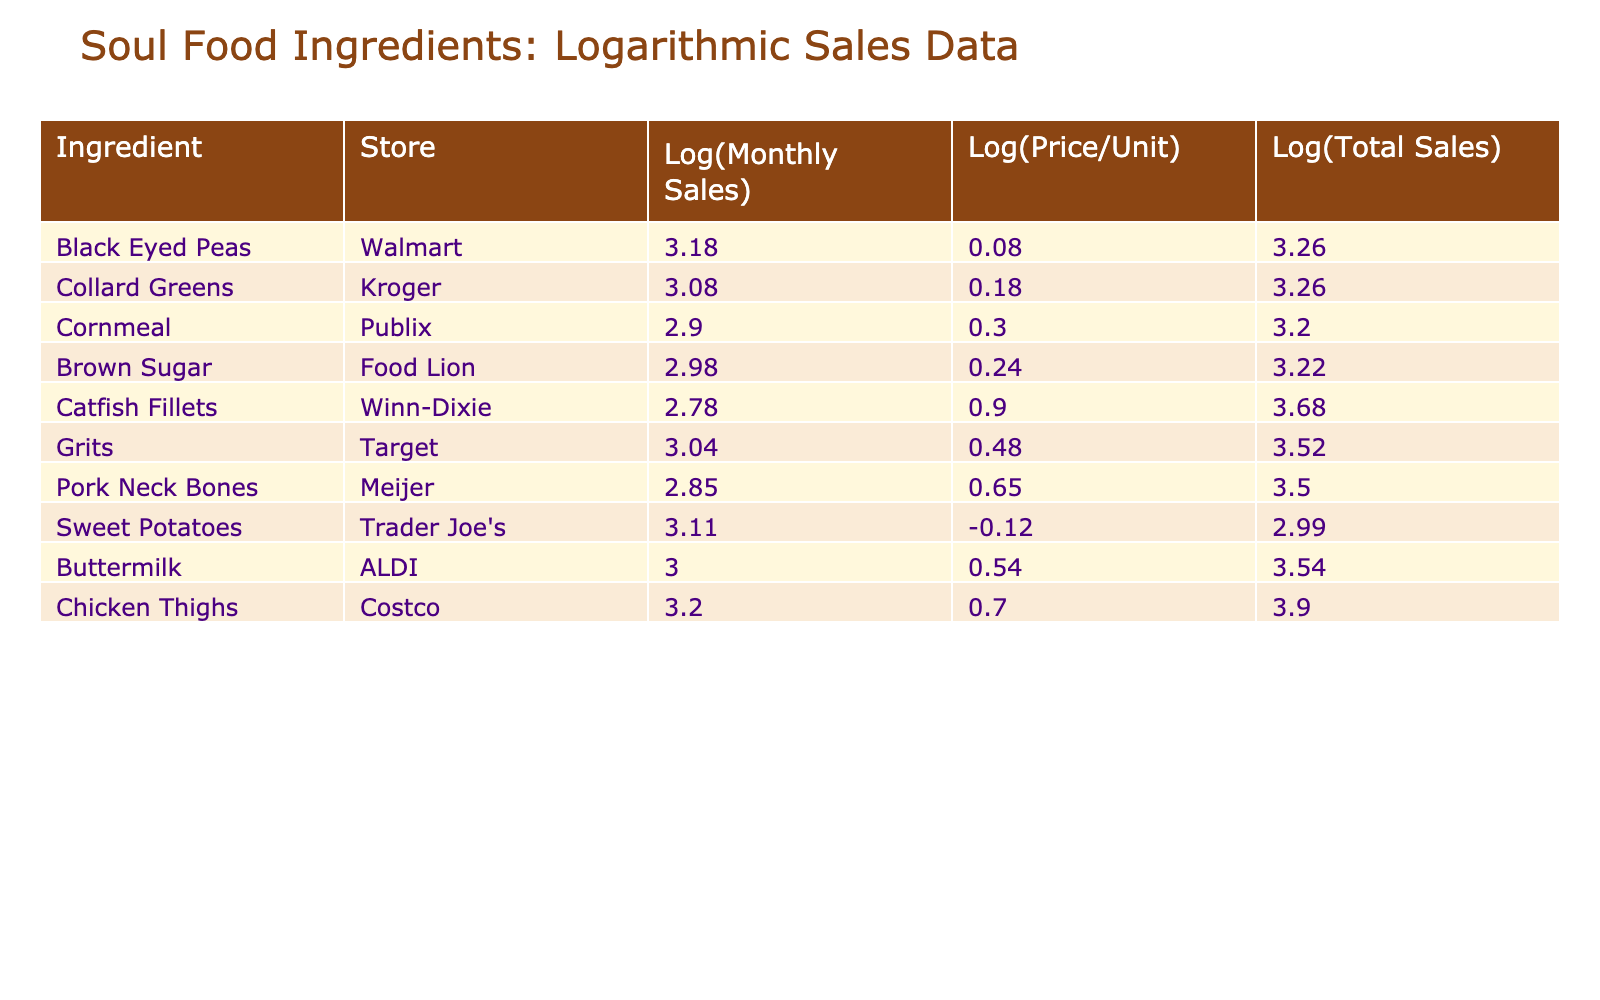What is the logarithmic value of the Monthly Sales Units for Catfish Fillets? The logarithmic value can be found in the "Log(Monthly Sales)" column for Catfish Fillets, which has 600 Monthly Sales Units. By calculating log10(600), we find it to be approximately 2.78.
Answer: 2.78 Which store sells the most log-transformed number of Monthly Sales Units of Grits? The log-transformed value for Grits in Target is found in the "Log(Monthly Sales)" column, which is approximately 3.04. There are no other stores selling Grits, so Target is the only store for this ingredient.
Answer: Target What is the total sales rounded to the nearest integer for the ingredient with the highest logarithmic value of Price Per Unit? The ingredient with the highest Price Per Unit is Catfish Fillets, priced at 8.00, and its Total Sales is 4800. The logarithmic value for Price Per Unit is log10(8.00) which is about 0.90. Hence, since it has the highest price, the Total Sales for Catfish Fillets is already known as 4800 when rounded to the nearest integer.
Answer: 4800 Is the log-transformed Total Sales of Black Eyed Peas greater than that of Collard Greens? The logarithmic value for Total Sales of Black Eyed Peas is log10(1800) which is approximately 3.25, while for Collard Greens the value is log10(1800), which is the same, approximately 3.25. Since they are equal, the statement is false.
Answer: No What are the average logarithmic values for Monthly Sales Units among the ingredients? To calculate the average, sum the logarithmic values of Monthly Sales Units for all ingredients: sum(3.18, 3.08, 2.90, 2.98, 2.78, 3.04, 2.84, 3.11, 3.00, 3.20) = 28.19, and divide by 10 (the total number of ingredients) gives approximately 2.82.
Answer: 2.82 